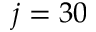<formula> <loc_0><loc_0><loc_500><loc_500>j = 3 0</formula> 